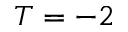<formula> <loc_0><loc_0><loc_500><loc_500>T = - 2</formula> 